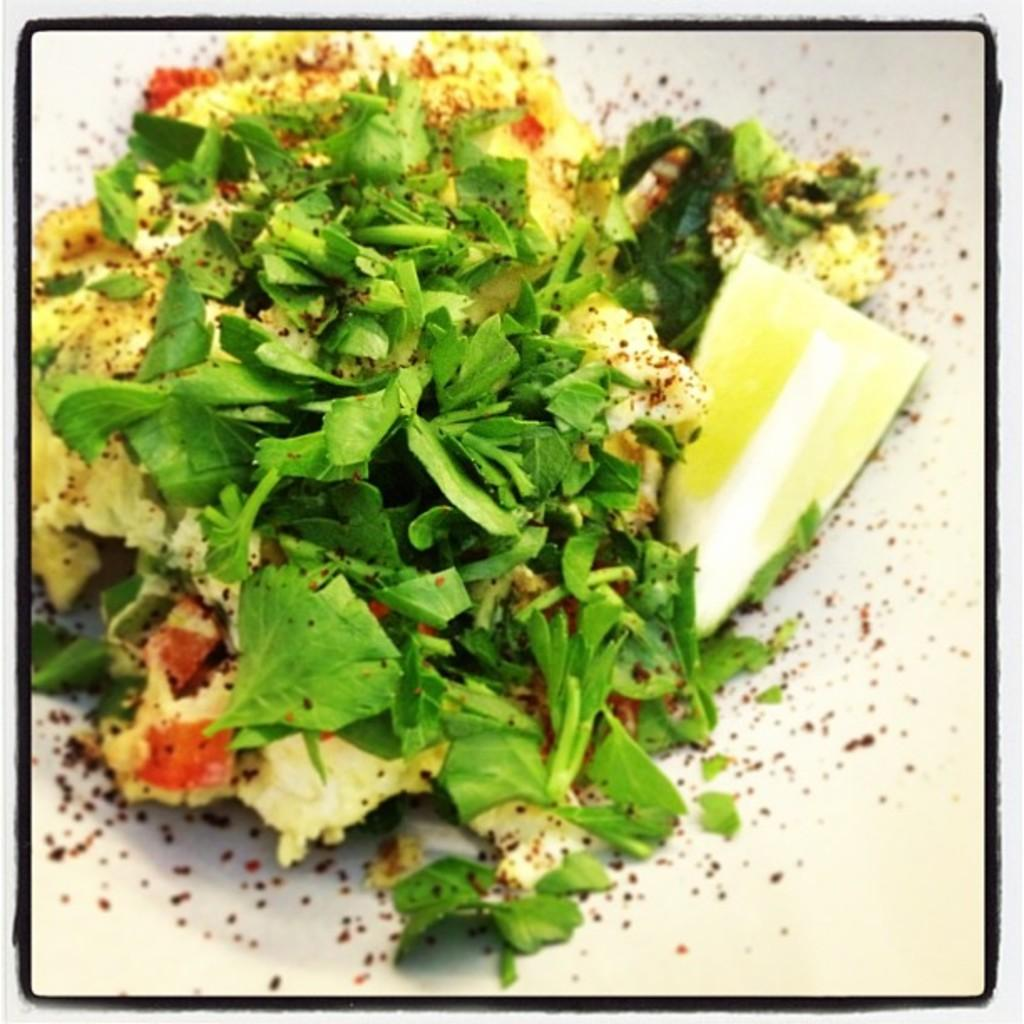What type of vegetables can be seen in the image? There are green leafy vegetables in the image. What other food items are present in the image besides the vegetables? Unfortunately, the provided facts do not mention any other food items in the image. What is the main topic of the protest happening in the image? There is no protest present in the image; it features green leafy vegetables and other unspecified food items. How does the vein in the image compare to the vein in another image? There is no vein present in the image; it only contains green leafy vegetables and other unspecified food items. 